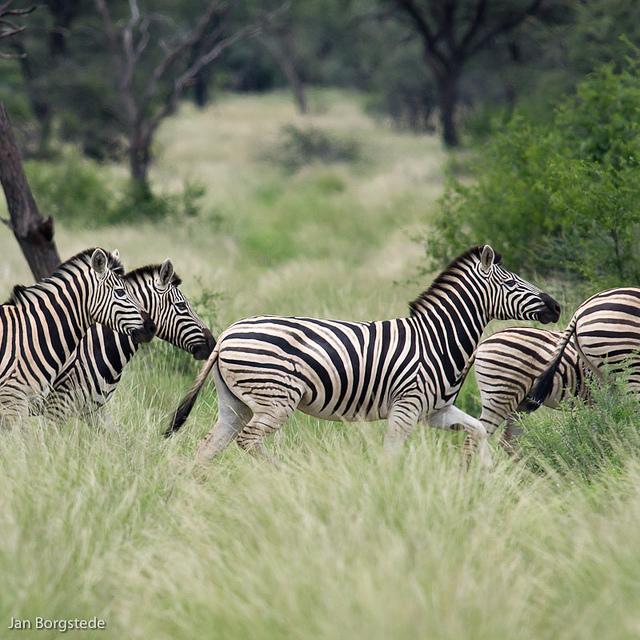What colors can you see in the picture?
Give a very brief answer. Green, black and white. How many zebra heads can you see?
Keep it brief. 3. What kind of animals are those?
Answer briefly. Zebras. Is this a tour bus?
Quick response, please. No. 